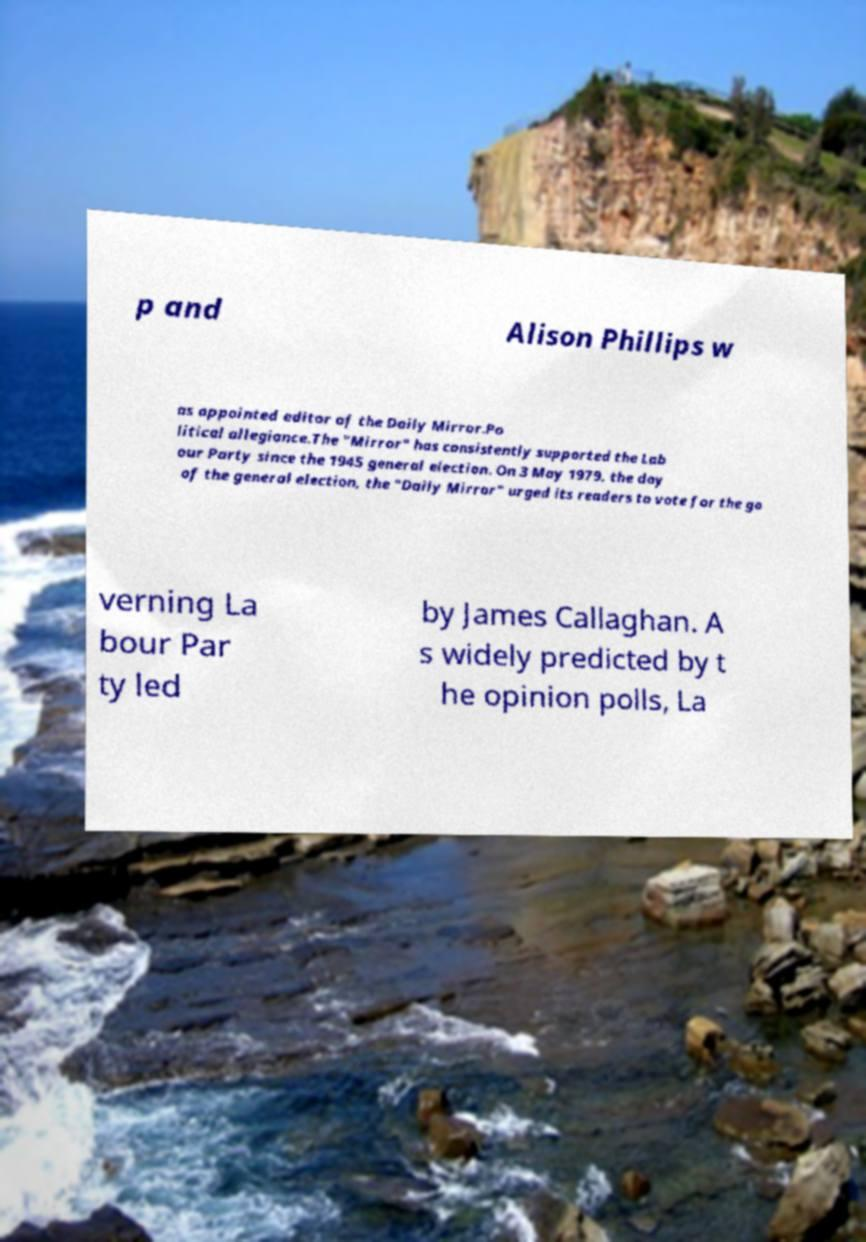Can you read and provide the text displayed in the image?This photo seems to have some interesting text. Can you extract and type it out for me? p and Alison Phillips w as appointed editor of the Daily Mirror.Po litical allegiance.The "Mirror" has consistently supported the Lab our Party since the 1945 general election. On 3 May 1979, the day of the general election, the "Daily Mirror" urged its readers to vote for the go verning La bour Par ty led by James Callaghan. A s widely predicted by t he opinion polls, La 